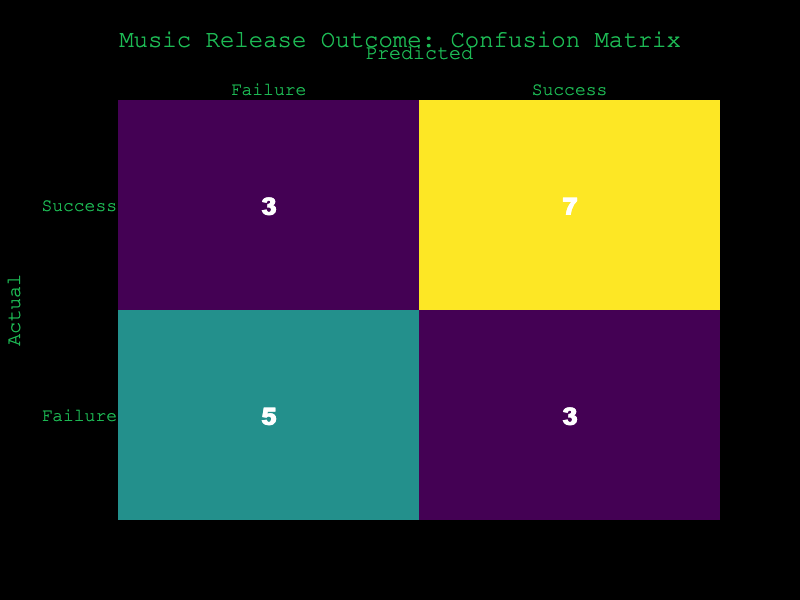What is the total number of music releases classified as "Success"? To find this, we count the occurrences of "Success" in the Actual column. In the data, there are 10 instances of "Success".
Answer: 10 What is the total number of music releases classified as "Failure"? To find this, we count the occurrences of "Failure" in the Actual column. In the data, there are 6 instances of "Failure".
Answer: 6 How many times was a "Success" predicted when the actual outcome was "Failure"? We look at the intersection of Actual being "Failure" and Predicted being "Success". There are 3 occurrences where "Failure" is the Actual and "Success" is the Predicted.
Answer: 3 What is the total number of music releases correctly predicted as "Success"? We need to find the number of times "Success" appears in both the Actual and Predicted columns. There are 7 instances that fit this criterion.
Answer: 7 How many times were music releases incorrectly classified as "Failure" when they were actually "Success"? We're looking for "Success" in the Actual column and "Failure" in the Predicted column. There are 3 instances of this.
Answer: 3 What is the overall accuracy of the predictions? Accuracy is calculated by taking the number of correct predictions (both successes and failures) divided by the total number of releases. (7 correct Success + 3 correct Failure) / 16 total = 10 / 16 = 0.625.
Answer: 62.5% How many total predictions were made in which the Actual outcome was "Success"? The total number of predictions for "Success" is the same as the total counted under Actual "Success", which is 10.
Answer: 10 Is it true that more music releases were classified as "Success" than "Failure"? Looking at the counts, there are 10 instances of "Success" and 6 instances of "Failure". Thus, it is true that more were classified as "Success".
Answer: Yes What is the percentage of predicted outcomes that were actually successful? To find this percentage, we take the number of correctly predicted successes (7) and divide it by the total predictions made (16), then multiply by 100. (7 / 16) * 100 = 43.75%.
Answer: 43.75% 